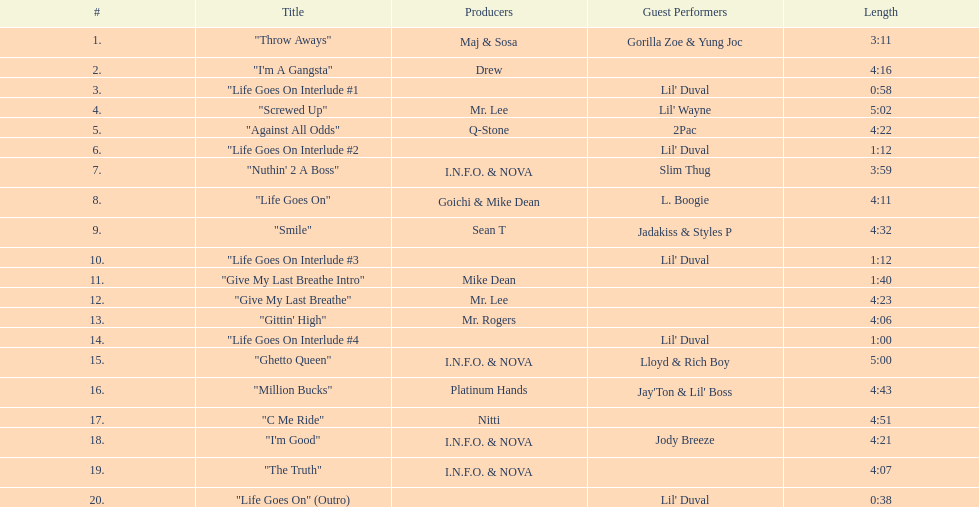What is the lengthiest track on the album? "Screwed Up". 